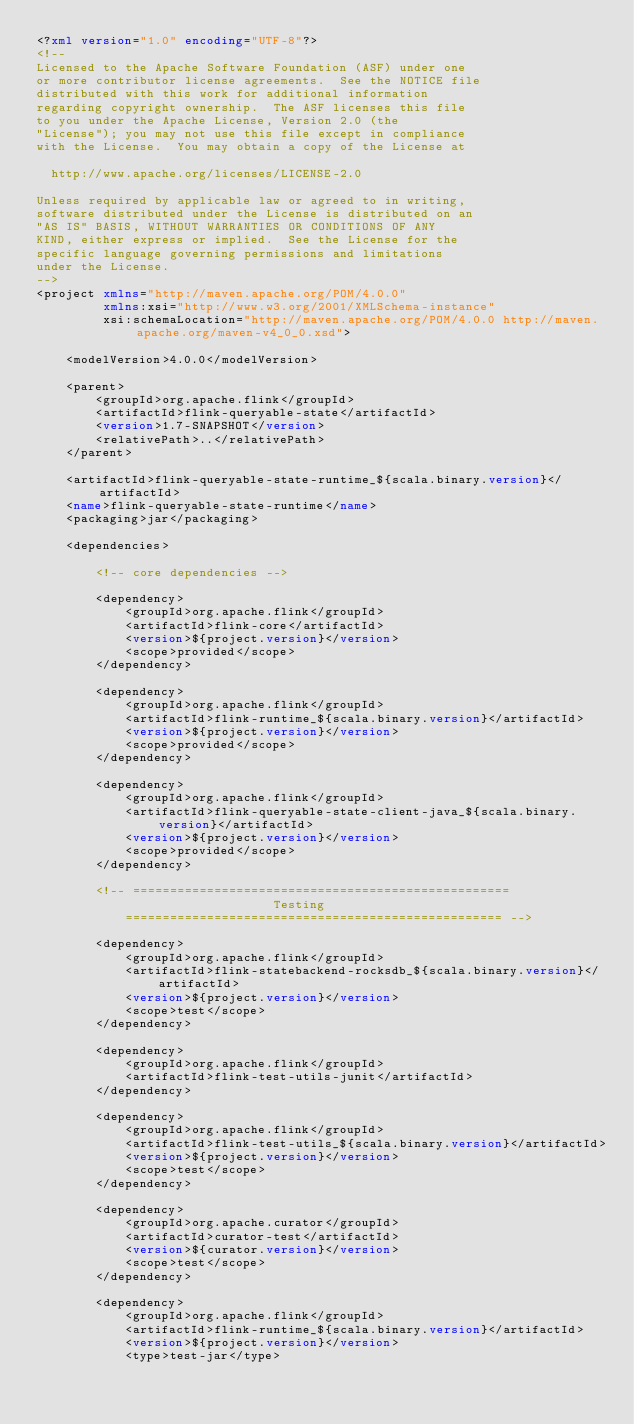Convert code to text. <code><loc_0><loc_0><loc_500><loc_500><_XML_><?xml version="1.0" encoding="UTF-8"?>
<!--
Licensed to the Apache Software Foundation (ASF) under one
or more contributor license agreements.  See the NOTICE file
distributed with this work for additional information
regarding copyright ownership.  The ASF licenses this file
to you under the Apache License, Version 2.0 (the
"License"); you may not use this file except in compliance
with the License.  You may obtain a copy of the License at

  http://www.apache.org/licenses/LICENSE-2.0

Unless required by applicable law or agreed to in writing,
software distributed under the License is distributed on an
"AS IS" BASIS, WITHOUT WARRANTIES OR CONDITIONS OF ANY
KIND, either express or implied.  See the License for the
specific language governing permissions and limitations
under the License.
-->
<project xmlns="http://maven.apache.org/POM/4.0.0"
		 xmlns:xsi="http://www.w3.org/2001/XMLSchema-instance"
		 xsi:schemaLocation="http://maven.apache.org/POM/4.0.0 http://maven.apache.org/maven-v4_0_0.xsd">

	<modelVersion>4.0.0</modelVersion>

	<parent>
		<groupId>org.apache.flink</groupId>
		<artifactId>flink-queryable-state</artifactId>
		<version>1.7-SNAPSHOT</version>
		<relativePath>..</relativePath>
	</parent>

	<artifactId>flink-queryable-state-runtime_${scala.binary.version}</artifactId>
	<name>flink-queryable-state-runtime</name>
	<packaging>jar</packaging>

	<dependencies>

		<!-- core dependencies -->

		<dependency>
			<groupId>org.apache.flink</groupId>
			<artifactId>flink-core</artifactId>
			<version>${project.version}</version>
			<scope>provided</scope>
		</dependency>

		<dependency>
			<groupId>org.apache.flink</groupId>
			<artifactId>flink-runtime_${scala.binary.version}</artifactId>
			<version>${project.version}</version>
			<scope>provided</scope>
		</dependency>

		<dependency>
			<groupId>org.apache.flink</groupId>
			<artifactId>flink-queryable-state-client-java_${scala.binary.version}</artifactId>
			<version>${project.version}</version>
			<scope>provided</scope>
		</dependency>

		<!-- ===================================================
								Testing
			=================================================== -->

		<dependency>
			<groupId>org.apache.flink</groupId>
			<artifactId>flink-statebackend-rocksdb_${scala.binary.version}</artifactId>
			<version>${project.version}</version>
			<scope>test</scope>
		</dependency>

		<dependency>
			<groupId>org.apache.flink</groupId>
			<artifactId>flink-test-utils-junit</artifactId>
		</dependency>

		<dependency>
			<groupId>org.apache.flink</groupId>
			<artifactId>flink-test-utils_${scala.binary.version}</artifactId>
			<version>${project.version}</version>
			<scope>test</scope>
		</dependency>

		<dependency>
			<groupId>org.apache.curator</groupId>
			<artifactId>curator-test</artifactId>
			<version>${curator.version}</version>
			<scope>test</scope>
		</dependency>

		<dependency>
			<groupId>org.apache.flink</groupId>
			<artifactId>flink-runtime_${scala.binary.version}</artifactId>
			<version>${project.version}</version>
			<type>test-jar</type></code> 